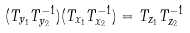<formula> <loc_0><loc_0><loc_500><loc_500>( T _ { y _ { 1 } } T _ { y _ { 2 } } ^ { - 1 } ) ( T _ { x _ { 1 } } T _ { x _ { 2 } } ^ { - 1 } ) = T _ { z _ { 1 } } T _ { z _ { 2 } } ^ { - 1 }</formula> 